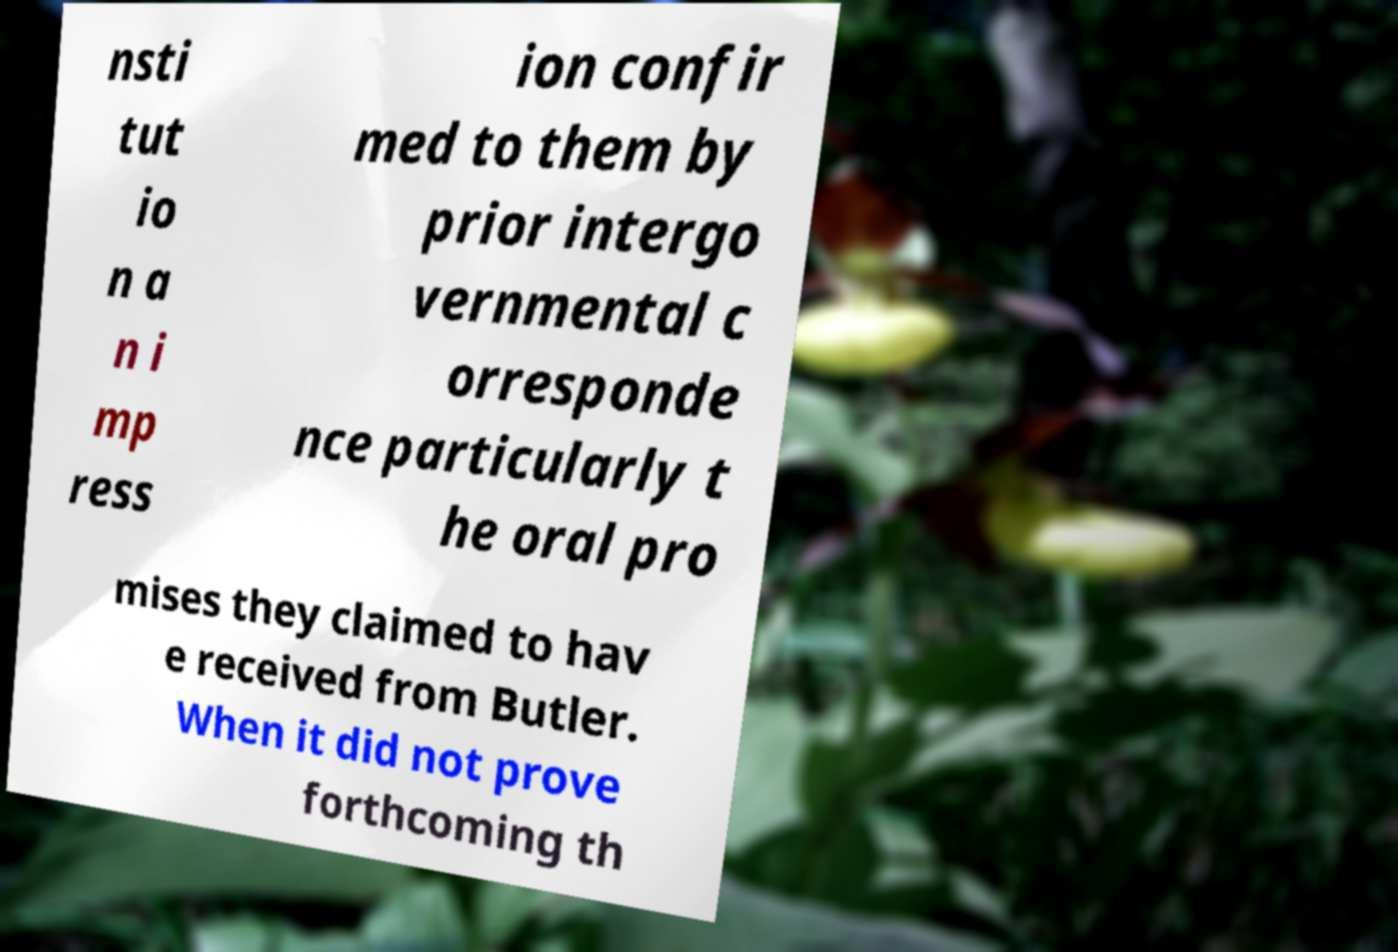Can you read and provide the text displayed in the image?This photo seems to have some interesting text. Can you extract and type it out for me? nsti tut io n a n i mp ress ion confir med to them by prior intergo vernmental c orresponde nce particularly t he oral pro mises they claimed to hav e received from Butler. When it did not prove forthcoming th 